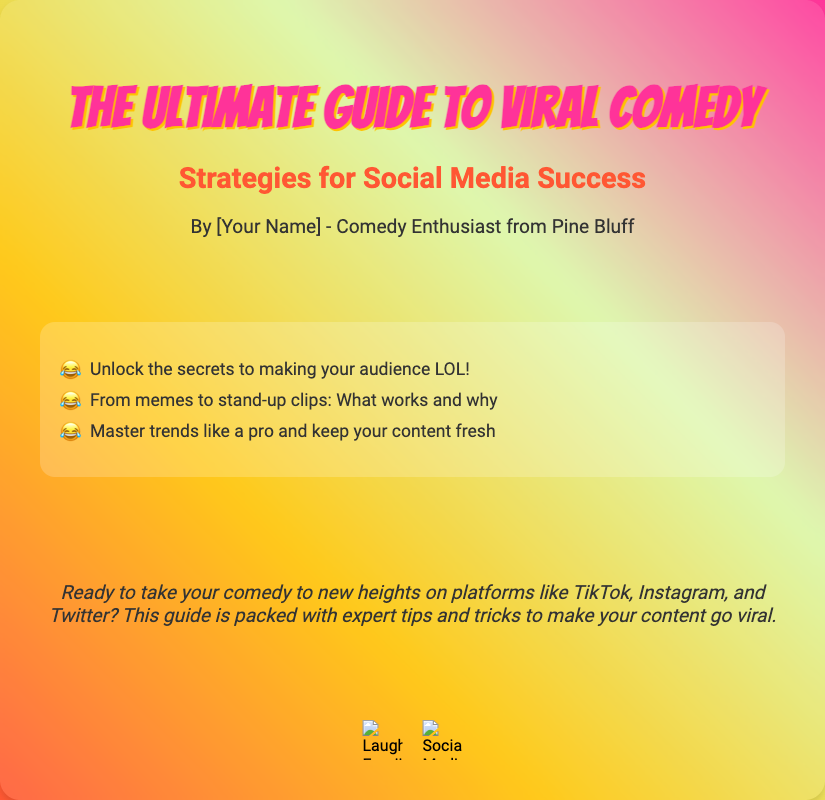What is the title of the book? The title is prominently displayed at the top of the book cover, highlighting the main focus of the document.
Answer: The Ultimate Guide to Viral Comedy Who is the author? The author's name is mentioned below the title and subtitle, indicating their connection to the content.
Answer: [Your Name] What are the three highlights listed? The highlights provide key points about the book's content, specifically the strategies discussed inside.
Answer: Unlock the secrets to making your audience LOL!, From memes to stand-up clips: What works and why, Master trends like a pro and keep your content fresh What is the subtitle of the book? The subtitle is located just below the title, adding context to the main theme of the book.
Answer: Strategies for Social Media Success What is the main purpose of the book? The teaser at the bottom of the cover gives insight into the primary goal of the book, targeting aspiring comedians.
Answer: To take your comedy to new heights on platforms like TikTok, Instagram, and Twitter How does the cover design convey the theme? The use of vibrant colors, playful fonts, and illustrations emphasizes a fun, approachable vibe, aligning with the subject of comedy.
Answer: Vibrant colors and playful fonts What kind of content can readers expect? The highlights indicate the variety of comedic techniques and strategies that will be covered in the book.
Answer: Techniques for viral comedy content What types of social media are mentioned? The teaser discusses specific platforms where the strategies can be applied, helping clarify the book's relevance.
Answer: TikTok, Instagram, and Twitter What visual elements are included on the cover? The design description lists specific graphics and icons that enhance the visual appeal and relate to the comedy theme.
Answer: Laughing emojis and social media icons 